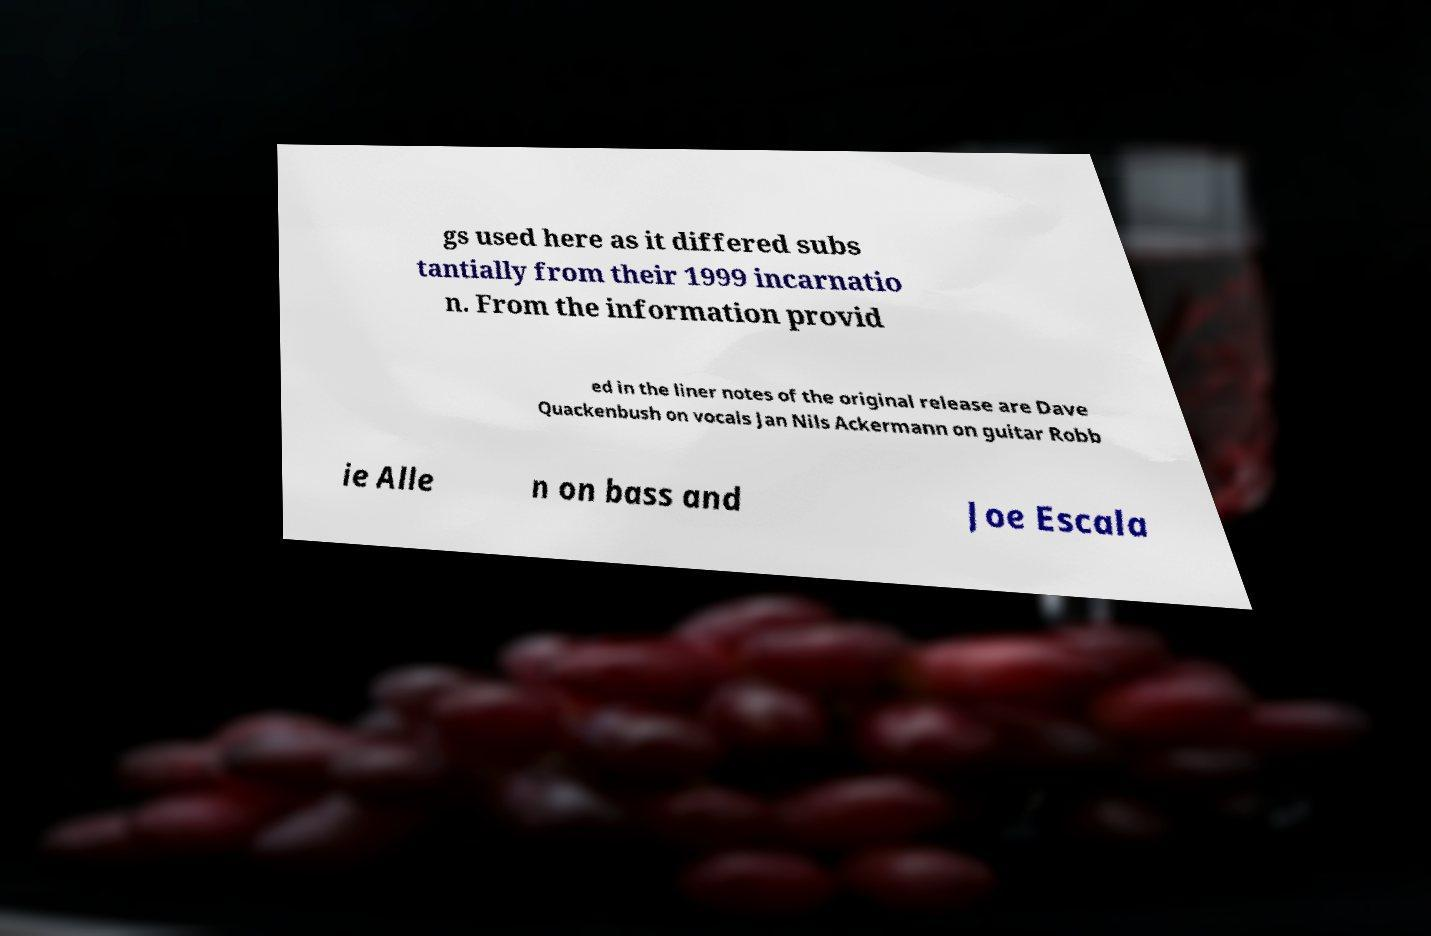Please read and relay the text visible in this image. What does it say? gs used here as it differed subs tantially from their 1999 incarnatio n. From the information provid ed in the liner notes of the original release are Dave Quackenbush on vocals Jan Nils Ackermann on guitar Robb ie Alle n on bass and Joe Escala 